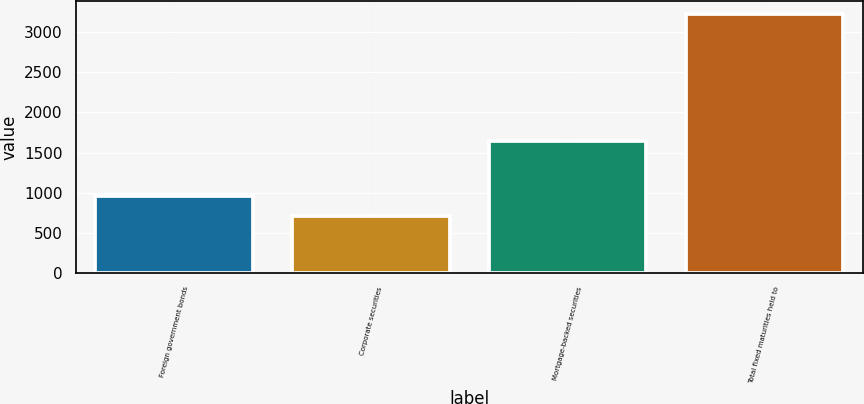<chart> <loc_0><loc_0><loc_500><loc_500><bar_chart><fcel>Foreign government bonds<fcel>Corporate securities<fcel>Mortgage-backed securities<fcel>Total fixed maturities held to<nl><fcel>956.4<fcel>704<fcel>1643<fcel>3228<nl></chart> 